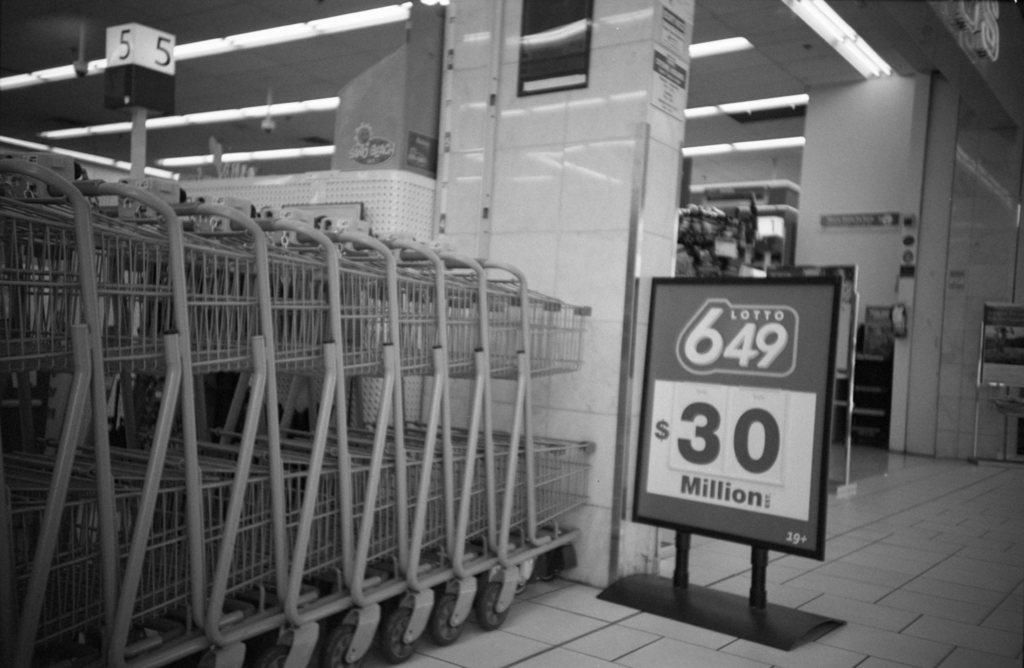<image>
Render a clear and concise summary of the photo. Lottery signing showing the winning pot is 30 million in a grocery store beside carts. 